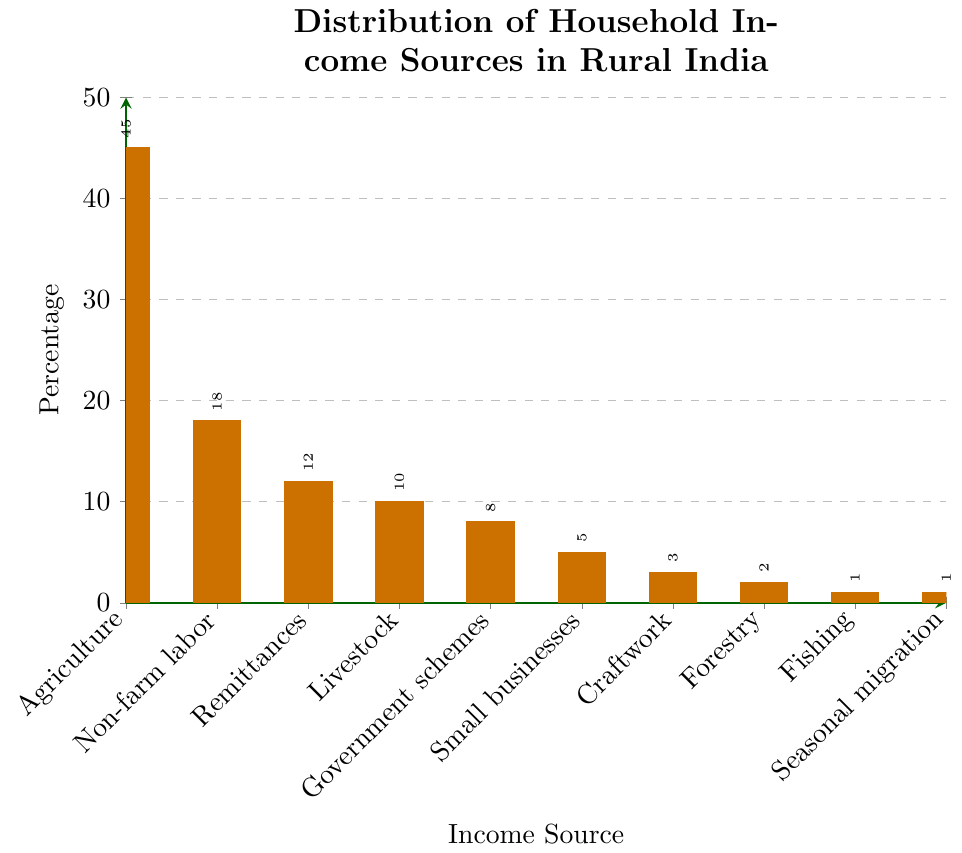Which income source has the highest percentage? The bar for Agriculture is the tallest, which indicates it has the highest percentage at 45%.
Answer: Agriculture What is the combined percentage of Remittances, Livestock, and Government schemes? Add the percentages for Remittances (12%), Livestock (10%), and Government schemes (8%): 12 + 10 + 8 = 30.
Answer: 30% Which two income sources have exactly 1% each? The bars for Fishing and Seasonal migration are both at 1%.
Answer: Fishing, Seasonal migration Which income source has the smallest contribution? Both Fishing and Seasonal migration have the smallest bar height at 1% each.
Answer: Fishing, Seasonal migration How much more significant is Agriculture compared to Non-farm labor? The difference between Agriculture (45%) and Non-farm labor (18%) is 45 - 18 = 27.
Answer: 27% What are the top three income sources? The three tallest bars are for Agriculture (45%), Non-farm labor (18%), and Remittances (12%).
Answer: Agriculture, Non-farm labor, Remittances What percentage of households rely on Government schemes and Small businesses combined? Add the percentages for Government schemes (8%) and Small businesses (5%): 8 + 5 = 13.
Answer: 13% What percentage of income is not generated from Agriculture? Subtract the percentage for Agriculture (45%) from 100%: 100 - 45 = 55.
Answer: 55% How many income sources contribute less than 5% each? The bars for Craftwork (3%), Forestry (2%), Fishing (1%), and Seasonal migration (1%) are all less than 5%, totaling four sources.
Answer: 4 If we combine Livestock and Non-farm labor, do they surpass Agriculture in percentage? Add the percentages for Livestock (10%) and Non-farm labor (18%): 10 + 18 = 28, which is less than Agriculture (45%).
Answer: No 